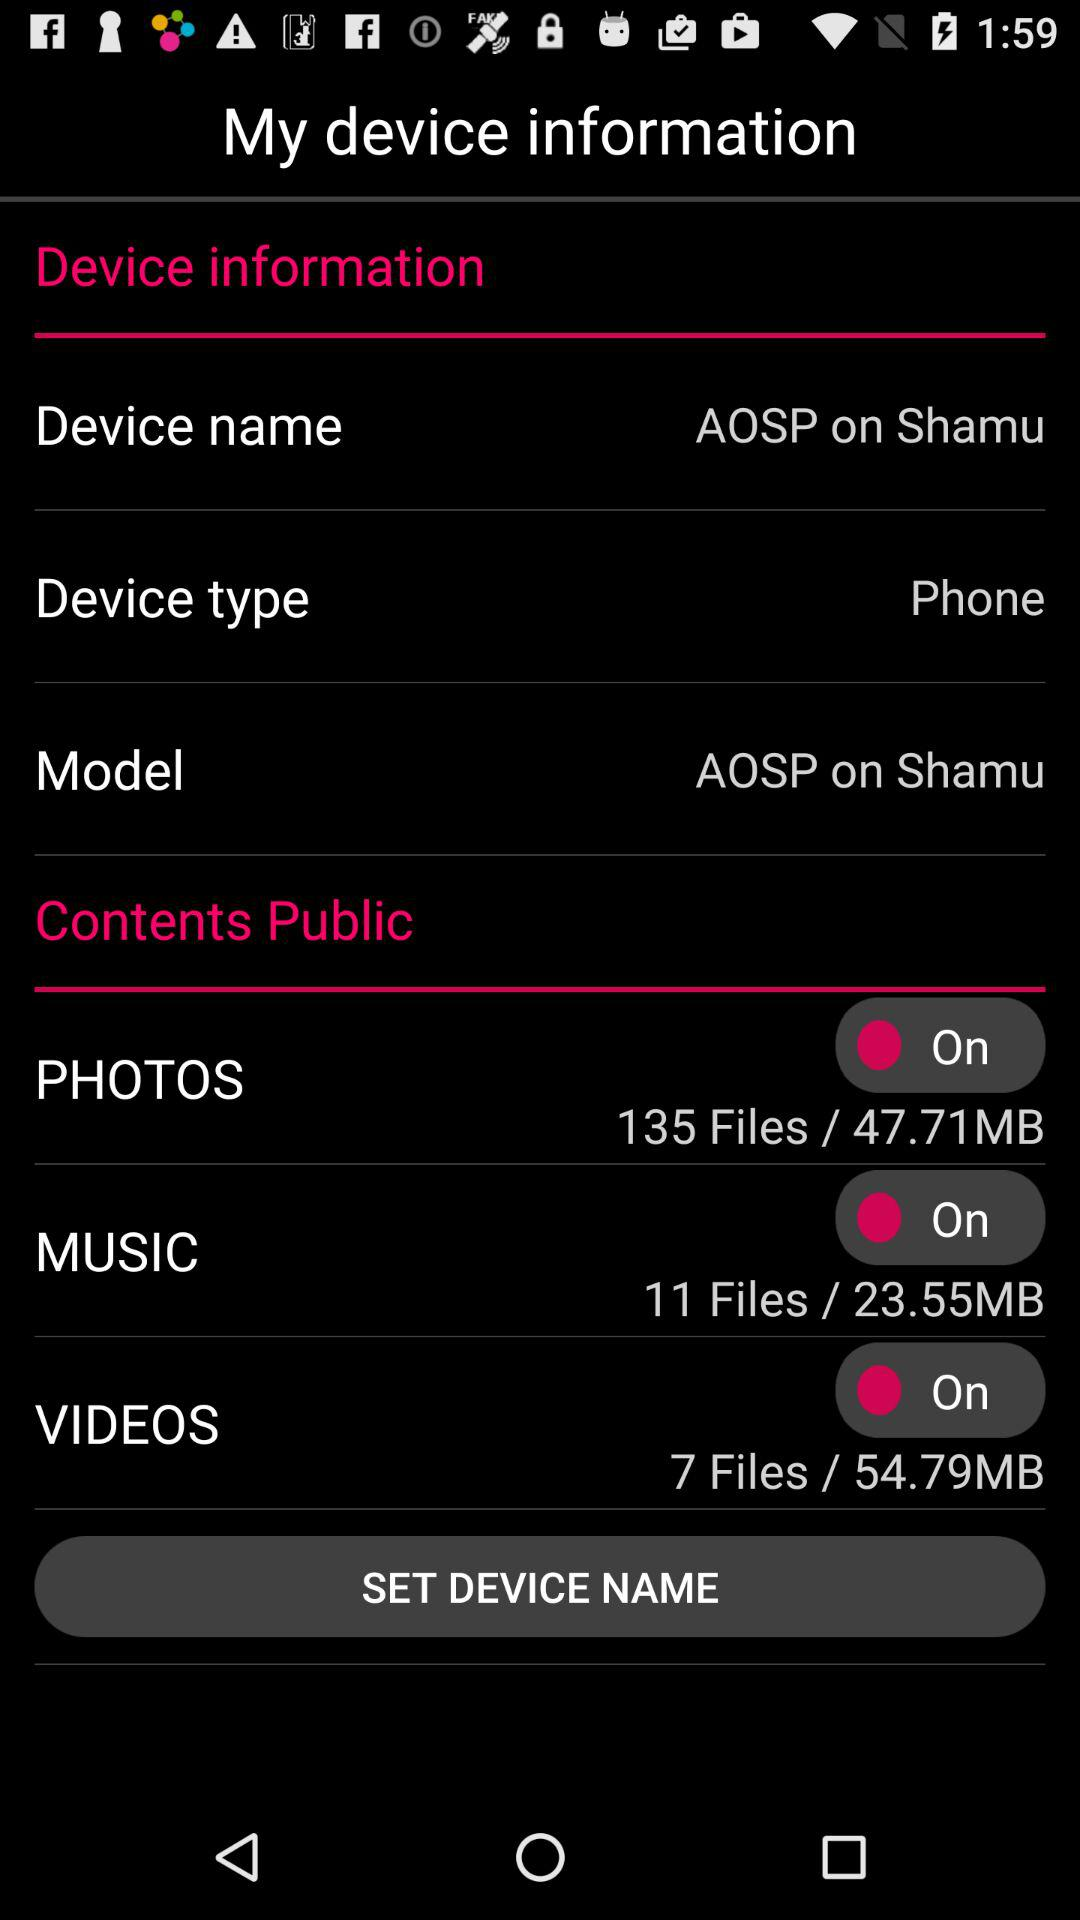What model is available on the screen? The model is "AOSP on Shamu". 